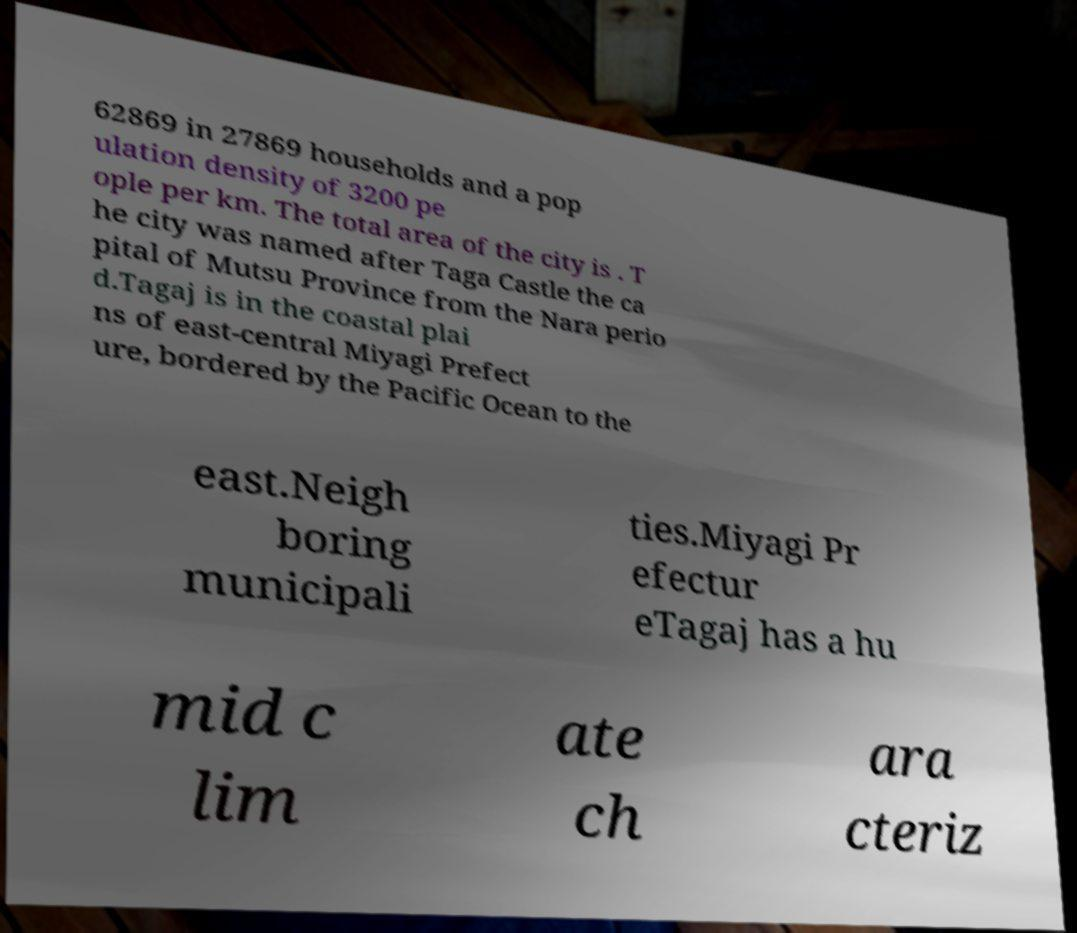Please read and relay the text visible in this image. What does it say? 62869 in 27869 households and a pop ulation density of 3200 pe ople per km. The total area of the city is . T he city was named after Taga Castle the ca pital of Mutsu Province from the Nara perio d.Tagaj is in the coastal plai ns of east-central Miyagi Prefect ure, bordered by the Pacific Ocean to the east.Neigh boring municipali ties.Miyagi Pr efectur eTagaj has a hu mid c lim ate ch ara cteriz 